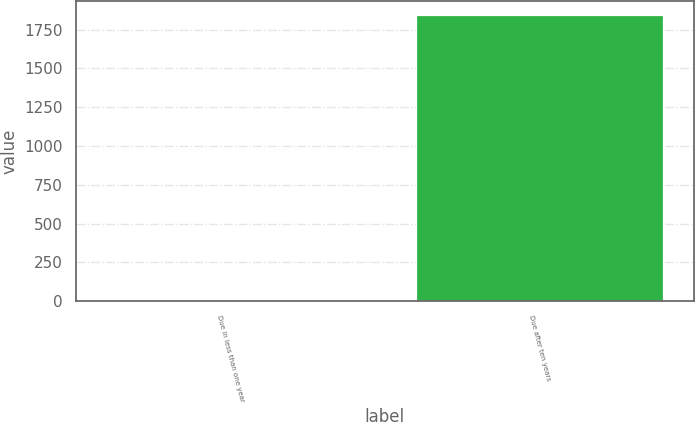<chart> <loc_0><loc_0><loc_500><loc_500><bar_chart><fcel>Due in less than one year<fcel>Due after ten years<nl><fcel>9<fcel>1843<nl></chart> 